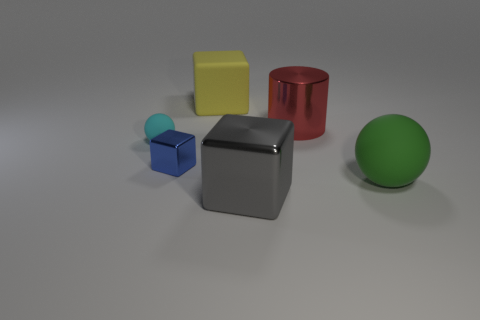Subtract all big matte blocks. How many blocks are left? 2 Add 3 large gray cubes. How many objects exist? 9 Subtract all green balls. How many balls are left? 1 Subtract 1 cubes. How many cubes are left? 2 Add 5 gray objects. How many gray objects exist? 6 Subtract 0 green cubes. How many objects are left? 6 Subtract all spheres. How many objects are left? 4 Subtract all purple cubes. Subtract all brown balls. How many cubes are left? 3 Subtract all large matte things. Subtract all matte blocks. How many objects are left? 3 Add 4 green things. How many green things are left? 5 